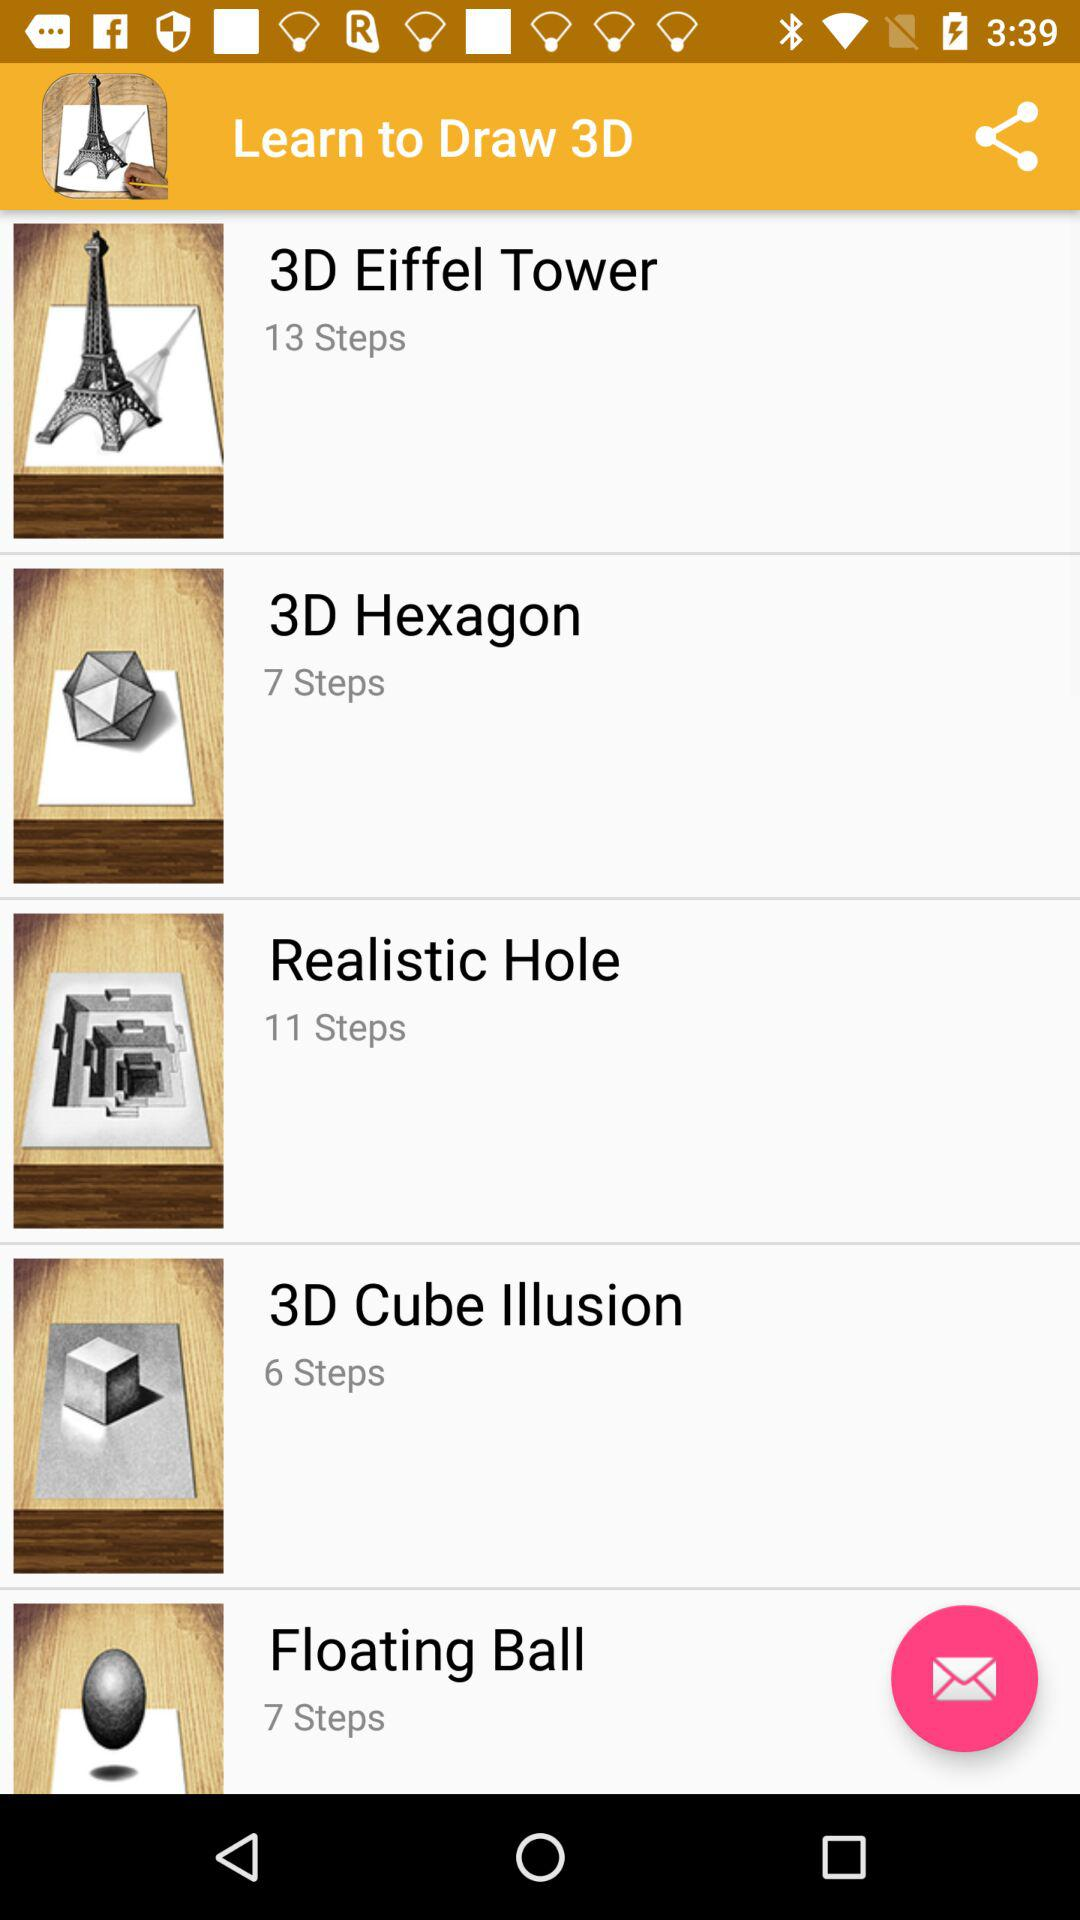What is the number of steps for drawing a 3D Eiffel Tower? The number of steps for drawing a 3D Eiffel Tower is 13. 